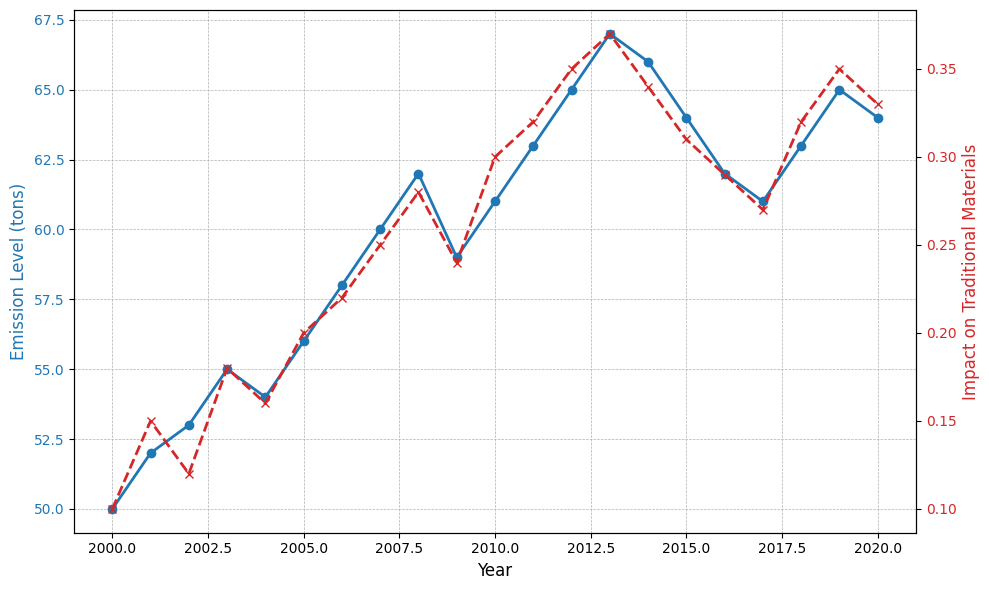How do the emission levels in 2020 compare to those in 2000? Look at the emission levels for 2000 (50 tons) and 2020 (64 tons). The emission level in 2020 is higher.
Answer: 2020 is higher What is the general trend of the impact on traditional materials from 2000 to 2020? Observe the line for the impact on traditional materials from 2000 (0.1) to 2020 (0.33). The line generally rises, indicating an increasing trend.
Answer: Increasing In which year did the emission levels reach their peak? Identify the highest point on the emission level line. The peak occurs in 2013 at 67 tons.
Answer: 2013 What is the difference between the emission levels in 2010 and 2012? Emissions in 2010 were 61 tons, and in 2012 they were 65 tons. The difference is 65 - 61 = 4 tons.
Answer: 4 tons During which years did the impact on traditional materials remain the same as the previous year? Look for years where the 'Impact on Traditional Materials' value did not change from the previous year. From the plot, impacts from 2018 and 2019 are both 0.35.
Answer: 2019 What is the average emission level from 2015 to 2020? Sum the emission levels from 2015 (64), 2016 (62), 2017 (61), 2018 (63), 2019 (65), and 2020 (64) and divide by the number of years: (64 + 62 + 61 + 63 + 65 + 64) / 6 = 63.17 tons.
Answer: 63.17 tons Which year saw the largest single-year increase in impact on traditional materials? Find the year with the greatest difference between two consecutive points on the impact line. The largest increase is from 2011 (0.32) to 2012 (0.35), with a difference of 0.03.
Answer: 2012 When did the emission levels drop for the first time since 2000? Look for the first instance where the emission level decreases compared to the previous year. The first drop occurs from 2008 (62 tons) to 2009 (59 tons).
Answer: 2009 